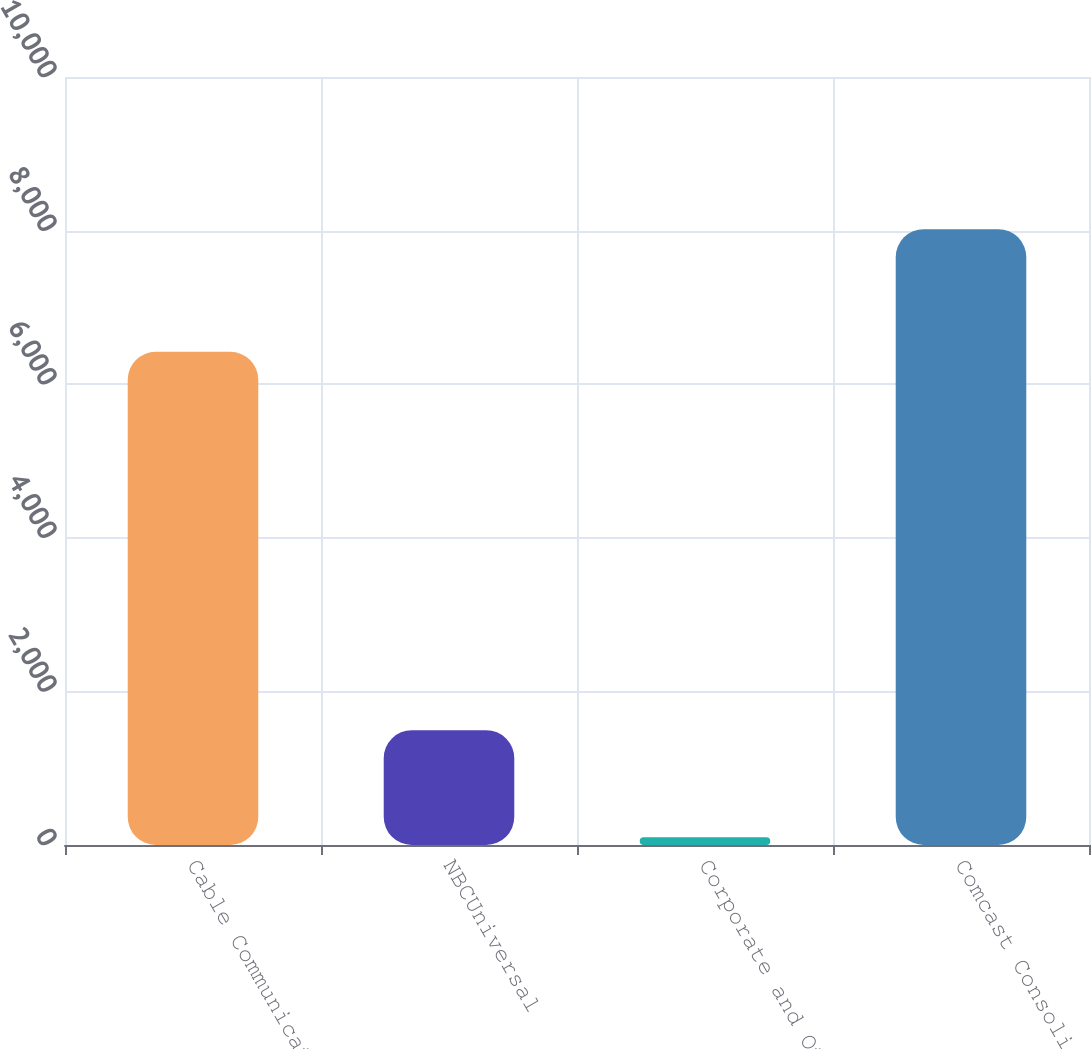Convert chart. <chart><loc_0><loc_0><loc_500><loc_500><bar_chart><fcel>Cable Communications<fcel>NBCUniversal<fcel>Corporate and Other<fcel>Comcast Consolidated<nl><fcel>6422<fcel>1495<fcel>102<fcel>8019<nl></chart> 